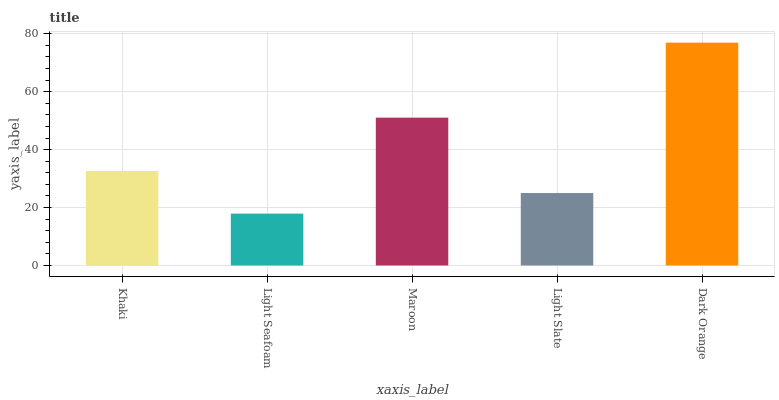Is Maroon the minimum?
Answer yes or no. No. Is Maroon the maximum?
Answer yes or no. No. Is Maroon greater than Light Seafoam?
Answer yes or no. Yes. Is Light Seafoam less than Maroon?
Answer yes or no. Yes. Is Light Seafoam greater than Maroon?
Answer yes or no. No. Is Maroon less than Light Seafoam?
Answer yes or no. No. Is Khaki the high median?
Answer yes or no. Yes. Is Khaki the low median?
Answer yes or no. Yes. Is Dark Orange the high median?
Answer yes or no. No. Is Light Seafoam the low median?
Answer yes or no. No. 